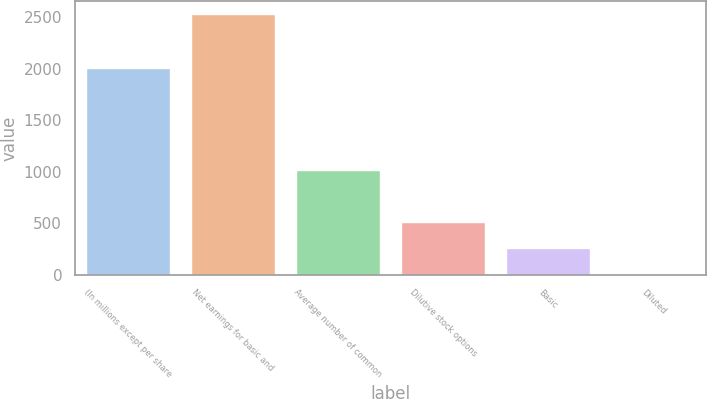<chart> <loc_0><loc_0><loc_500><loc_500><bar_chart><fcel>(In millions except per share<fcel>Net earnings for basic and<fcel>Average number of common<fcel>Dilutive stock options<fcel>Basic<fcel>Diluted<nl><fcel>2006<fcel>2529<fcel>1015.08<fcel>510.44<fcel>258.12<fcel>5.8<nl></chart> 